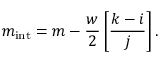<formula> <loc_0><loc_0><loc_500><loc_500>m _ { i n t } = m - { \frac { w } { 2 } } \left [ { \frac { k - i } { j } } \right ] .</formula> 